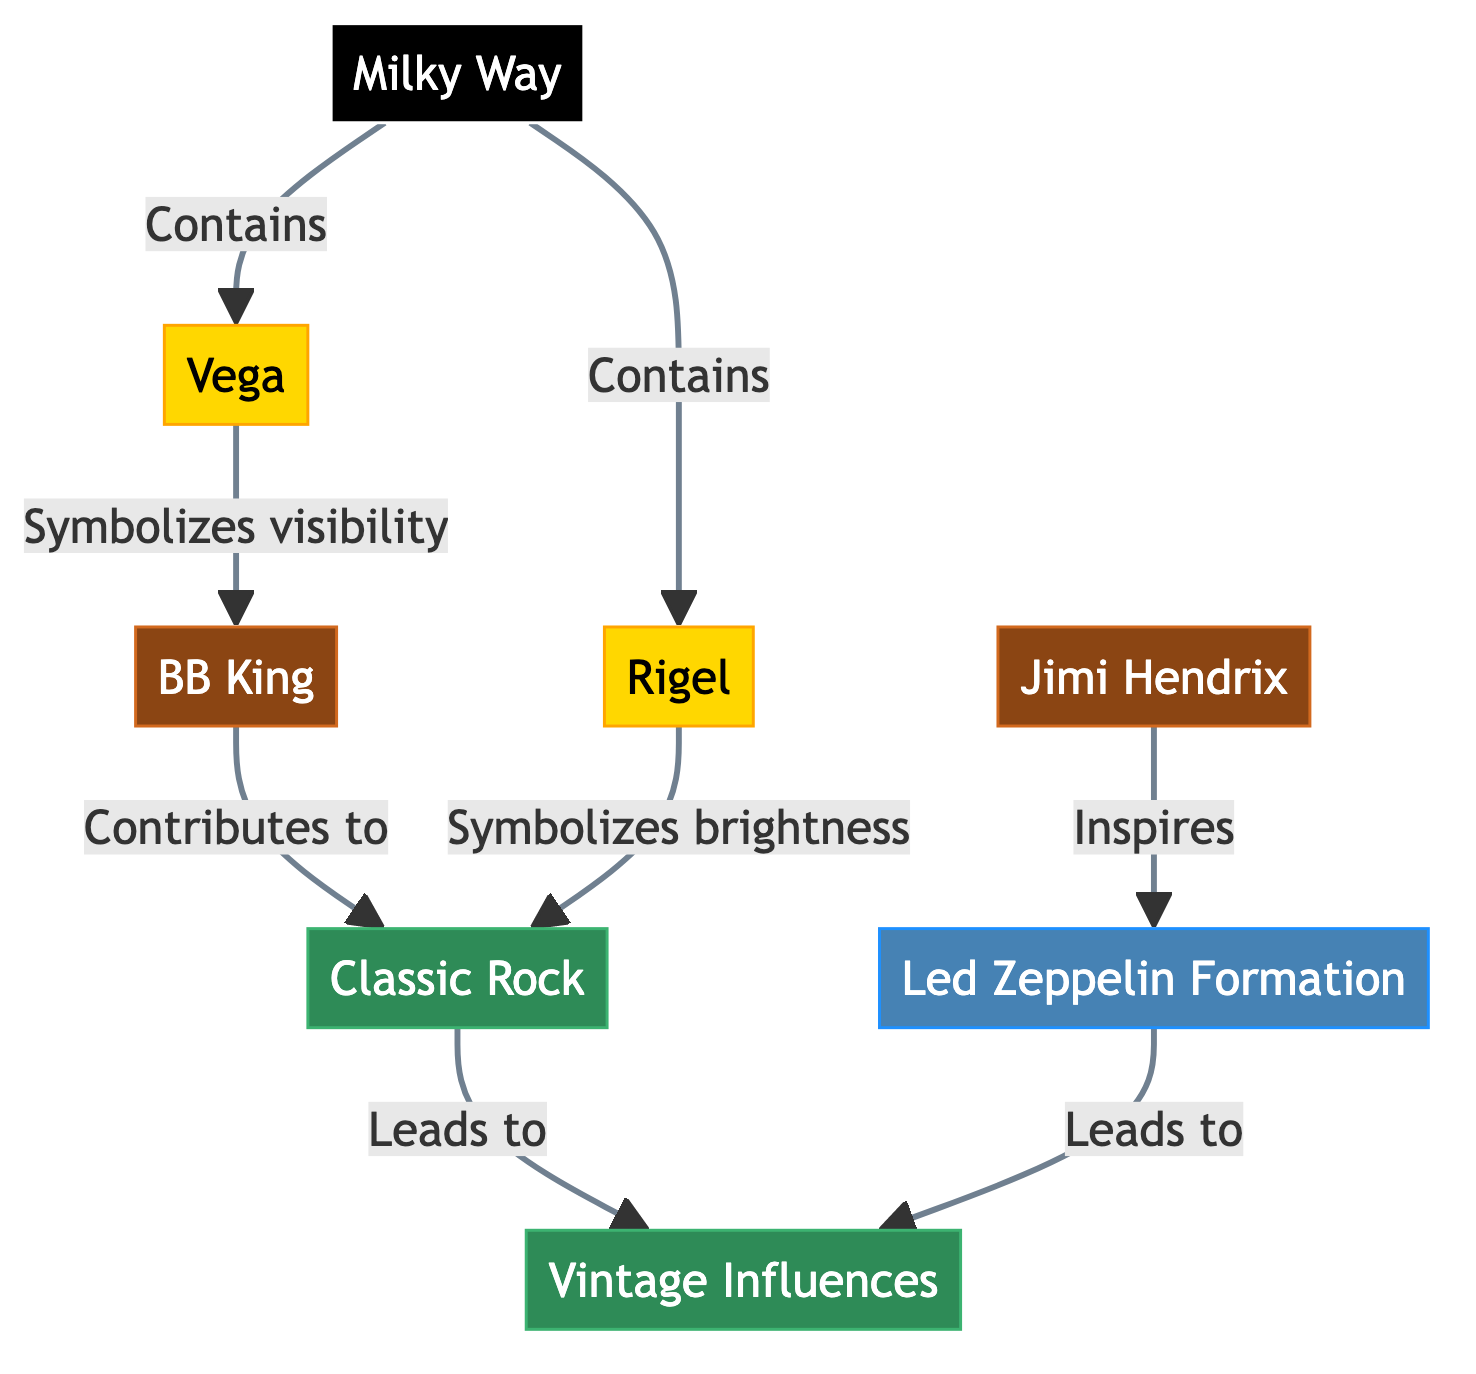What is the brightness symbolized by Rigel? In the diagram, Rigel directly points to "Classic Rock" with the label "Symbolizes brightness." This indicates that Rigel represents the brightness aspect tied to classic rock, thus confirming its association with that concept.
Answer: Classic Rock How many stars are included in the Milky Way? The Milky Way node contains two stars: Rigel and Vega. Counting both nodes connected to Milky Way gives us the total number of stars, which is 2.
Answer: 2 Which rock legend contributes to Classic Rock? The diagram shows that BB King has a direct connection labeled "Contributes to" pointing towards "Classic Rock." This clearly indicates that BB King plays a role in contributing to this genre.
Answer: BB King What is the relationship between Jimi Hendrix and Led Zeppelin Formation? In the diagram, Jimi Hendrix is connected to Led Zeppelin Formation with the direction labeled "Inspires." This relationship indicates that Jimi Hendrix serves as an inspiration for the formation of Led Zeppelin.
Answer: Inspires Which star symbolizes visibility? The diagram states that Vega "Symbolizes visibility." This designation explicitly identifies Vega as representing visibility in the context presented.
Answer: Vega How many milestones are represented in the diagram? The diagram has one milestone, which is "Led Zeppelin Formation." Since there is only one node labeled as a milestone in the diagram, the total count is 1.
Answer: 1 What does Vintage Influences relate to? The arrow from "Classic Rock" points to "Vintage Influences," indicating that Vintage Influences are related or derived from the Classic Rock genre. This relationship shows the influence of classic rock on vintage music elements.
Answer: Classic Rock How does the visibility of Vega correlate with BB King's contributions? The diagram captures a connection between Vega, which symbolizes visibility, and BB King, who contributes to Classic Rock. This implies that the visibility associated with Vega relates to BB King's impact on that genre in a more artistic sense.
Answer: Classic Rock What are the two concepts presented in the diagram? The diagram contains two concept nodes: "Classic Rock" and "Vintage Influences." This can be directly observed through the connection layout showing both concepts' titles.
Answer: Classic Rock, Vintage Influences 